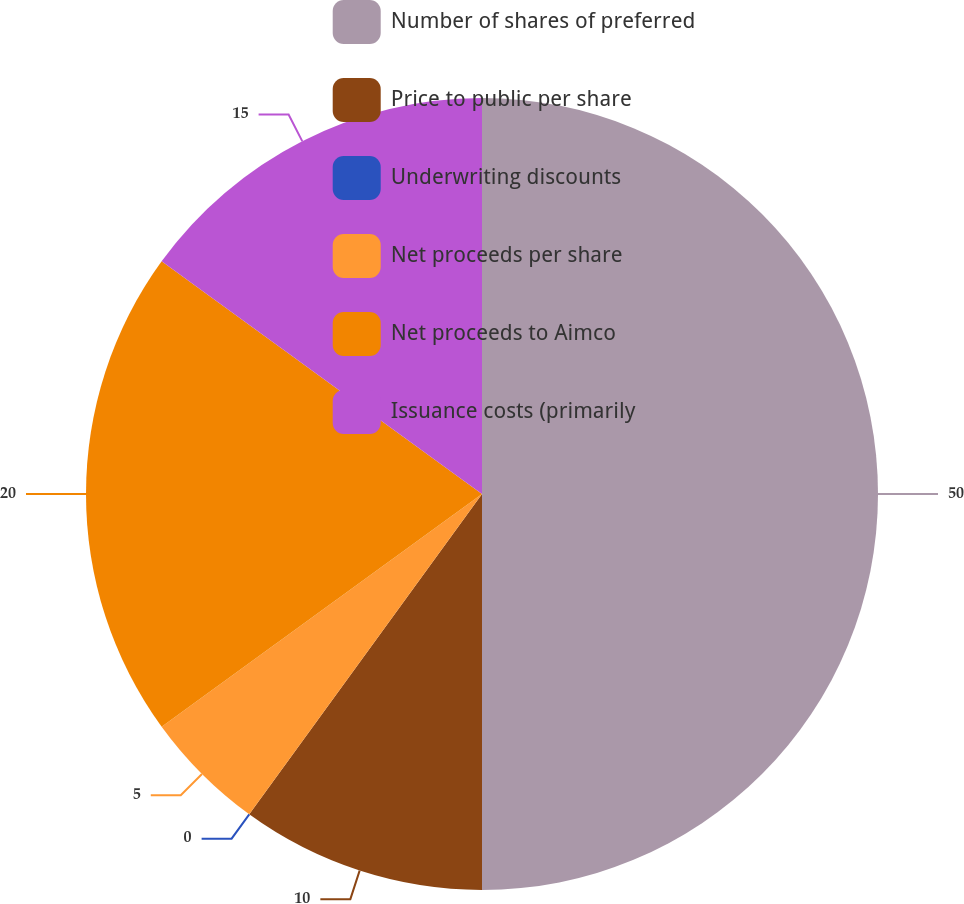Convert chart to OTSL. <chart><loc_0><loc_0><loc_500><loc_500><pie_chart><fcel>Number of shares of preferred<fcel>Price to public per share<fcel>Underwriting discounts<fcel>Net proceeds per share<fcel>Net proceeds to Aimco<fcel>Issuance costs (primarily<nl><fcel>50.0%<fcel>10.0%<fcel>0.0%<fcel>5.0%<fcel>20.0%<fcel>15.0%<nl></chart> 